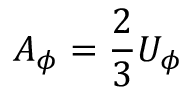Convert formula to latex. <formula><loc_0><loc_0><loc_500><loc_500>A _ { \phi } = \frac { 2 } { 3 } U _ { \phi }</formula> 